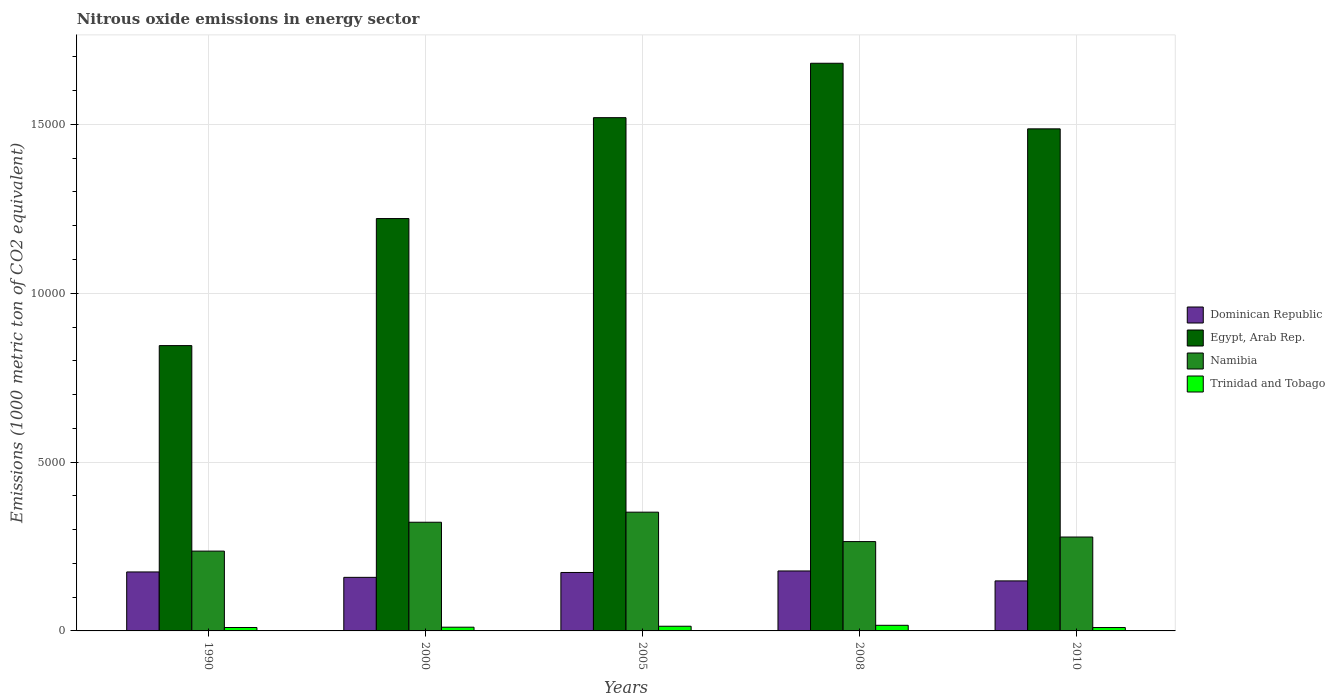How many different coloured bars are there?
Your response must be concise. 4. How many groups of bars are there?
Your answer should be very brief. 5. Are the number of bars per tick equal to the number of legend labels?
Offer a terse response. Yes. Are the number of bars on each tick of the X-axis equal?
Offer a terse response. Yes. How many bars are there on the 4th tick from the left?
Offer a terse response. 4. How many bars are there on the 1st tick from the right?
Keep it short and to the point. 4. What is the label of the 4th group of bars from the left?
Your answer should be very brief. 2008. What is the amount of nitrous oxide emitted in Namibia in 2010?
Provide a short and direct response. 2780.9. Across all years, what is the maximum amount of nitrous oxide emitted in Trinidad and Tobago?
Offer a very short reply. 166.3. Across all years, what is the minimum amount of nitrous oxide emitted in Dominican Republic?
Make the answer very short. 1481.5. In which year was the amount of nitrous oxide emitted in Egypt, Arab Rep. maximum?
Provide a succinct answer. 2008. What is the total amount of nitrous oxide emitted in Namibia in the graph?
Your answer should be very brief. 1.45e+04. What is the difference between the amount of nitrous oxide emitted in Namibia in 1990 and that in 2008?
Make the answer very short. -281.7. What is the difference between the amount of nitrous oxide emitted in Trinidad and Tobago in 2008 and the amount of nitrous oxide emitted in Egypt, Arab Rep. in 2010?
Offer a terse response. -1.47e+04. What is the average amount of nitrous oxide emitted in Namibia per year?
Give a very brief answer. 2905.14. In the year 2008, what is the difference between the amount of nitrous oxide emitted in Egypt, Arab Rep. and amount of nitrous oxide emitted in Trinidad and Tobago?
Make the answer very short. 1.66e+04. In how many years, is the amount of nitrous oxide emitted in Egypt, Arab Rep. greater than 13000 1000 metric ton?
Give a very brief answer. 3. What is the ratio of the amount of nitrous oxide emitted in Namibia in 2000 to that in 2005?
Provide a succinct answer. 0.92. Is the difference between the amount of nitrous oxide emitted in Egypt, Arab Rep. in 2000 and 2005 greater than the difference between the amount of nitrous oxide emitted in Trinidad and Tobago in 2000 and 2005?
Provide a succinct answer. No. What is the difference between the highest and the second highest amount of nitrous oxide emitted in Egypt, Arab Rep.?
Keep it short and to the point. 1611.4. What is the difference between the highest and the lowest amount of nitrous oxide emitted in Dominican Republic?
Ensure brevity in your answer.  294.2. Is the sum of the amount of nitrous oxide emitted in Trinidad and Tobago in 2000 and 2005 greater than the maximum amount of nitrous oxide emitted in Dominican Republic across all years?
Your answer should be compact. No. What does the 1st bar from the left in 2010 represents?
Offer a very short reply. Dominican Republic. What does the 4th bar from the right in 2005 represents?
Ensure brevity in your answer.  Dominican Republic. How many bars are there?
Your answer should be compact. 20. Are all the bars in the graph horizontal?
Your answer should be very brief. No. How many years are there in the graph?
Make the answer very short. 5. Does the graph contain any zero values?
Provide a short and direct response. No. Where does the legend appear in the graph?
Offer a terse response. Center right. What is the title of the graph?
Your answer should be very brief. Nitrous oxide emissions in energy sector. What is the label or title of the Y-axis?
Your response must be concise. Emissions (1000 metric ton of CO2 equivalent). What is the Emissions (1000 metric ton of CO2 equivalent) of Dominican Republic in 1990?
Offer a terse response. 1746.5. What is the Emissions (1000 metric ton of CO2 equivalent) in Egypt, Arab Rep. in 1990?
Your answer should be compact. 8449.9. What is the Emissions (1000 metric ton of CO2 equivalent) in Namibia in 1990?
Your response must be concise. 2363.8. What is the Emissions (1000 metric ton of CO2 equivalent) of Trinidad and Tobago in 1990?
Keep it short and to the point. 101.3. What is the Emissions (1000 metric ton of CO2 equivalent) of Dominican Republic in 2000?
Provide a succinct answer. 1586.4. What is the Emissions (1000 metric ton of CO2 equivalent) in Egypt, Arab Rep. in 2000?
Provide a short and direct response. 1.22e+04. What is the Emissions (1000 metric ton of CO2 equivalent) in Namibia in 2000?
Your response must be concise. 3218.7. What is the Emissions (1000 metric ton of CO2 equivalent) of Trinidad and Tobago in 2000?
Make the answer very short. 110.5. What is the Emissions (1000 metric ton of CO2 equivalent) in Dominican Republic in 2005?
Keep it short and to the point. 1731. What is the Emissions (1000 metric ton of CO2 equivalent) in Egypt, Arab Rep. in 2005?
Provide a succinct answer. 1.52e+04. What is the Emissions (1000 metric ton of CO2 equivalent) in Namibia in 2005?
Make the answer very short. 3516.8. What is the Emissions (1000 metric ton of CO2 equivalent) of Trinidad and Tobago in 2005?
Provide a short and direct response. 138.8. What is the Emissions (1000 metric ton of CO2 equivalent) in Dominican Republic in 2008?
Your answer should be compact. 1775.7. What is the Emissions (1000 metric ton of CO2 equivalent) of Egypt, Arab Rep. in 2008?
Your answer should be compact. 1.68e+04. What is the Emissions (1000 metric ton of CO2 equivalent) in Namibia in 2008?
Provide a succinct answer. 2645.5. What is the Emissions (1000 metric ton of CO2 equivalent) in Trinidad and Tobago in 2008?
Ensure brevity in your answer.  166.3. What is the Emissions (1000 metric ton of CO2 equivalent) of Dominican Republic in 2010?
Your answer should be compact. 1481.5. What is the Emissions (1000 metric ton of CO2 equivalent) of Egypt, Arab Rep. in 2010?
Your answer should be very brief. 1.49e+04. What is the Emissions (1000 metric ton of CO2 equivalent) in Namibia in 2010?
Your answer should be compact. 2780.9. What is the Emissions (1000 metric ton of CO2 equivalent) of Trinidad and Tobago in 2010?
Your answer should be very brief. 100.1. Across all years, what is the maximum Emissions (1000 metric ton of CO2 equivalent) of Dominican Republic?
Ensure brevity in your answer.  1775.7. Across all years, what is the maximum Emissions (1000 metric ton of CO2 equivalent) of Egypt, Arab Rep.?
Ensure brevity in your answer.  1.68e+04. Across all years, what is the maximum Emissions (1000 metric ton of CO2 equivalent) of Namibia?
Give a very brief answer. 3516.8. Across all years, what is the maximum Emissions (1000 metric ton of CO2 equivalent) in Trinidad and Tobago?
Provide a succinct answer. 166.3. Across all years, what is the minimum Emissions (1000 metric ton of CO2 equivalent) in Dominican Republic?
Your response must be concise. 1481.5. Across all years, what is the minimum Emissions (1000 metric ton of CO2 equivalent) of Egypt, Arab Rep.?
Keep it short and to the point. 8449.9. Across all years, what is the minimum Emissions (1000 metric ton of CO2 equivalent) in Namibia?
Offer a very short reply. 2363.8. Across all years, what is the minimum Emissions (1000 metric ton of CO2 equivalent) of Trinidad and Tobago?
Make the answer very short. 100.1. What is the total Emissions (1000 metric ton of CO2 equivalent) in Dominican Republic in the graph?
Make the answer very short. 8321.1. What is the total Emissions (1000 metric ton of CO2 equivalent) in Egypt, Arab Rep. in the graph?
Your answer should be compact. 6.75e+04. What is the total Emissions (1000 metric ton of CO2 equivalent) in Namibia in the graph?
Provide a succinct answer. 1.45e+04. What is the total Emissions (1000 metric ton of CO2 equivalent) of Trinidad and Tobago in the graph?
Keep it short and to the point. 617. What is the difference between the Emissions (1000 metric ton of CO2 equivalent) of Dominican Republic in 1990 and that in 2000?
Your answer should be very brief. 160.1. What is the difference between the Emissions (1000 metric ton of CO2 equivalent) of Egypt, Arab Rep. in 1990 and that in 2000?
Offer a terse response. -3762.5. What is the difference between the Emissions (1000 metric ton of CO2 equivalent) in Namibia in 1990 and that in 2000?
Ensure brevity in your answer.  -854.9. What is the difference between the Emissions (1000 metric ton of CO2 equivalent) of Trinidad and Tobago in 1990 and that in 2000?
Offer a very short reply. -9.2. What is the difference between the Emissions (1000 metric ton of CO2 equivalent) of Egypt, Arab Rep. in 1990 and that in 2005?
Make the answer very short. -6750.1. What is the difference between the Emissions (1000 metric ton of CO2 equivalent) in Namibia in 1990 and that in 2005?
Your answer should be very brief. -1153. What is the difference between the Emissions (1000 metric ton of CO2 equivalent) in Trinidad and Tobago in 1990 and that in 2005?
Provide a short and direct response. -37.5. What is the difference between the Emissions (1000 metric ton of CO2 equivalent) in Dominican Republic in 1990 and that in 2008?
Your answer should be very brief. -29.2. What is the difference between the Emissions (1000 metric ton of CO2 equivalent) in Egypt, Arab Rep. in 1990 and that in 2008?
Give a very brief answer. -8361.5. What is the difference between the Emissions (1000 metric ton of CO2 equivalent) of Namibia in 1990 and that in 2008?
Your answer should be very brief. -281.7. What is the difference between the Emissions (1000 metric ton of CO2 equivalent) of Trinidad and Tobago in 1990 and that in 2008?
Ensure brevity in your answer.  -65. What is the difference between the Emissions (1000 metric ton of CO2 equivalent) of Dominican Republic in 1990 and that in 2010?
Your answer should be very brief. 265. What is the difference between the Emissions (1000 metric ton of CO2 equivalent) of Egypt, Arab Rep. in 1990 and that in 2010?
Make the answer very short. -6418.9. What is the difference between the Emissions (1000 metric ton of CO2 equivalent) in Namibia in 1990 and that in 2010?
Provide a short and direct response. -417.1. What is the difference between the Emissions (1000 metric ton of CO2 equivalent) in Trinidad and Tobago in 1990 and that in 2010?
Your answer should be very brief. 1.2. What is the difference between the Emissions (1000 metric ton of CO2 equivalent) of Dominican Republic in 2000 and that in 2005?
Make the answer very short. -144.6. What is the difference between the Emissions (1000 metric ton of CO2 equivalent) in Egypt, Arab Rep. in 2000 and that in 2005?
Offer a very short reply. -2987.6. What is the difference between the Emissions (1000 metric ton of CO2 equivalent) in Namibia in 2000 and that in 2005?
Give a very brief answer. -298.1. What is the difference between the Emissions (1000 metric ton of CO2 equivalent) of Trinidad and Tobago in 2000 and that in 2005?
Your answer should be compact. -28.3. What is the difference between the Emissions (1000 metric ton of CO2 equivalent) of Dominican Republic in 2000 and that in 2008?
Your answer should be compact. -189.3. What is the difference between the Emissions (1000 metric ton of CO2 equivalent) of Egypt, Arab Rep. in 2000 and that in 2008?
Your answer should be very brief. -4599. What is the difference between the Emissions (1000 metric ton of CO2 equivalent) of Namibia in 2000 and that in 2008?
Ensure brevity in your answer.  573.2. What is the difference between the Emissions (1000 metric ton of CO2 equivalent) of Trinidad and Tobago in 2000 and that in 2008?
Provide a succinct answer. -55.8. What is the difference between the Emissions (1000 metric ton of CO2 equivalent) of Dominican Republic in 2000 and that in 2010?
Provide a short and direct response. 104.9. What is the difference between the Emissions (1000 metric ton of CO2 equivalent) in Egypt, Arab Rep. in 2000 and that in 2010?
Offer a terse response. -2656.4. What is the difference between the Emissions (1000 metric ton of CO2 equivalent) in Namibia in 2000 and that in 2010?
Give a very brief answer. 437.8. What is the difference between the Emissions (1000 metric ton of CO2 equivalent) in Trinidad and Tobago in 2000 and that in 2010?
Make the answer very short. 10.4. What is the difference between the Emissions (1000 metric ton of CO2 equivalent) in Dominican Republic in 2005 and that in 2008?
Make the answer very short. -44.7. What is the difference between the Emissions (1000 metric ton of CO2 equivalent) of Egypt, Arab Rep. in 2005 and that in 2008?
Your answer should be very brief. -1611.4. What is the difference between the Emissions (1000 metric ton of CO2 equivalent) of Namibia in 2005 and that in 2008?
Provide a succinct answer. 871.3. What is the difference between the Emissions (1000 metric ton of CO2 equivalent) in Trinidad and Tobago in 2005 and that in 2008?
Your response must be concise. -27.5. What is the difference between the Emissions (1000 metric ton of CO2 equivalent) in Dominican Republic in 2005 and that in 2010?
Your response must be concise. 249.5. What is the difference between the Emissions (1000 metric ton of CO2 equivalent) of Egypt, Arab Rep. in 2005 and that in 2010?
Your answer should be very brief. 331.2. What is the difference between the Emissions (1000 metric ton of CO2 equivalent) of Namibia in 2005 and that in 2010?
Your answer should be compact. 735.9. What is the difference between the Emissions (1000 metric ton of CO2 equivalent) of Trinidad and Tobago in 2005 and that in 2010?
Give a very brief answer. 38.7. What is the difference between the Emissions (1000 metric ton of CO2 equivalent) of Dominican Republic in 2008 and that in 2010?
Your answer should be compact. 294.2. What is the difference between the Emissions (1000 metric ton of CO2 equivalent) in Egypt, Arab Rep. in 2008 and that in 2010?
Your response must be concise. 1942.6. What is the difference between the Emissions (1000 metric ton of CO2 equivalent) in Namibia in 2008 and that in 2010?
Give a very brief answer. -135.4. What is the difference between the Emissions (1000 metric ton of CO2 equivalent) in Trinidad and Tobago in 2008 and that in 2010?
Your answer should be very brief. 66.2. What is the difference between the Emissions (1000 metric ton of CO2 equivalent) in Dominican Republic in 1990 and the Emissions (1000 metric ton of CO2 equivalent) in Egypt, Arab Rep. in 2000?
Ensure brevity in your answer.  -1.05e+04. What is the difference between the Emissions (1000 metric ton of CO2 equivalent) of Dominican Republic in 1990 and the Emissions (1000 metric ton of CO2 equivalent) of Namibia in 2000?
Provide a short and direct response. -1472.2. What is the difference between the Emissions (1000 metric ton of CO2 equivalent) in Dominican Republic in 1990 and the Emissions (1000 metric ton of CO2 equivalent) in Trinidad and Tobago in 2000?
Make the answer very short. 1636. What is the difference between the Emissions (1000 metric ton of CO2 equivalent) in Egypt, Arab Rep. in 1990 and the Emissions (1000 metric ton of CO2 equivalent) in Namibia in 2000?
Offer a very short reply. 5231.2. What is the difference between the Emissions (1000 metric ton of CO2 equivalent) in Egypt, Arab Rep. in 1990 and the Emissions (1000 metric ton of CO2 equivalent) in Trinidad and Tobago in 2000?
Provide a succinct answer. 8339.4. What is the difference between the Emissions (1000 metric ton of CO2 equivalent) of Namibia in 1990 and the Emissions (1000 metric ton of CO2 equivalent) of Trinidad and Tobago in 2000?
Make the answer very short. 2253.3. What is the difference between the Emissions (1000 metric ton of CO2 equivalent) of Dominican Republic in 1990 and the Emissions (1000 metric ton of CO2 equivalent) of Egypt, Arab Rep. in 2005?
Offer a terse response. -1.35e+04. What is the difference between the Emissions (1000 metric ton of CO2 equivalent) in Dominican Republic in 1990 and the Emissions (1000 metric ton of CO2 equivalent) in Namibia in 2005?
Give a very brief answer. -1770.3. What is the difference between the Emissions (1000 metric ton of CO2 equivalent) of Dominican Republic in 1990 and the Emissions (1000 metric ton of CO2 equivalent) of Trinidad and Tobago in 2005?
Your answer should be compact. 1607.7. What is the difference between the Emissions (1000 metric ton of CO2 equivalent) of Egypt, Arab Rep. in 1990 and the Emissions (1000 metric ton of CO2 equivalent) of Namibia in 2005?
Your answer should be very brief. 4933.1. What is the difference between the Emissions (1000 metric ton of CO2 equivalent) in Egypt, Arab Rep. in 1990 and the Emissions (1000 metric ton of CO2 equivalent) in Trinidad and Tobago in 2005?
Provide a short and direct response. 8311.1. What is the difference between the Emissions (1000 metric ton of CO2 equivalent) of Namibia in 1990 and the Emissions (1000 metric ton of CO2 equivalent) of Trinidad and Tobago in 2005?
Keep it short and to the point. 2225. What is the difference between the Emissions (1000 metric ton of CO2 equivalent) of Dominican Republic in 1990 and the Emissions (1000 metric ton of CO2 equivalent) of Egypt, Arab Rep. in 2008?
Your response must be concise. -1.51e+04. What is the difference between the Emissions (1000 metric ton of CO2 equivalent) in Dominican Republic in 1990 and the Emissions (1000 metric ton of CO2 equivalent) in Namibia in 2008?
Ensure brevity in your answer.  -899. What is the difference between the Emissions (1000 metric ton of CO2 equivalent) in Dominican Republic in 1990 and the Emissions (1000 metric ton of CO2 equivalent) in Trinidad and Tobago in 2008?
Give a very brief answer. 1580.2. What is the difference between the Emissions (1000 metric ton of CO2 equivalent) of Egypt, Arab Rep. in 1990 and the Emissions (1000 metric ton of CO2 equivalent) of Namibia in 2008?
Your answer should be very brief. 5804.4. What is the difference between the Emissions (1000 metric ton of CO2 equivalent) of Egypt, Arab Rep. in 1990 and the Emissions (1000 metric ton of CO2 equivalent) of Trinidad and Tobago in 2008?
Your response must be concise. 8283.6. What is the difference between the Emissions (1000 metric ton of CO2 equivalent) of Namibia in 1990 and the Emissions (1000 metric ton of CO2 equivalent) of Trinidad and Tobago in 2008?
Give a very brief answer. 2197.5. What is the difference between the Emissions (1000 metric ton of CO2 equivalent) in Dominican Republic in 1990 and the Emissions (1000 metric ton of CO2 equivalent) in Egypt, Arab Rep. in 2010?
Offer a very short reply. -1.31e+04. What is the difference between the Emissions (1000 metric ton of CO2 equivalent) in Dominican Republic in 1990 and the Emissions (1000 metric ton of CO2 equivalent) in Namibia in 2010?
Keep it short and to the point. -1034.4. What is the difference between the Emissions (1000 metric ton of CO2 equivalent) of Dominican Republic in 1990 and the Emissions (1000 metric ton of CO2 equivalent) of Trinidad and Tobago in 2010?
Your response must be concise. 1646.4. What is the difference between the Emissions (1000 metric ton of CO2 equivalent) in Egypt, Arab Rep. in 1990 and the Emissions (1000 metric ton of CO2 equivalent) in Namibia in 2010?
Keep it short and to the point. 5669. What is the difference between the Emissions (1000 metric ton of CO2 equivalent) in Egypt, Arab Rep. in 1990 and the Emissions (1000 metric ton of CO2 equivalent) in Trinidad and Tobago in 2010?
Your answer should be very brief. 8349.8. What is the difference between the Emissions (1000 metric ton of CO2 equivalent) in Namibia in 1990 and the Emissions (1000 metric ton of CO2 equivalent) in Trinidad and Tobago in 2010?
Ensure brevity in your answer.  2263.7. What is the difference between the Emissions (1000 metric ton of CO2 equivalent) of Dominican Republic in 2000 and the Emissions (1000 metric ton of CO2 equivalent) of Egypt, Arab Rep. in 2005?
Offer a very short reply. -1.36e+04. What is the difference between the Emissions (1000 metric ton of CO2 equivalent) of Dominican Republic in 2000 and the Emissions (1000 metric ton of CO2 equivalent) of Namibia in 2005?
Offer a terse response. -1930.4. What is the difference between the Emissions (1000 metric ton of CO2 equivalent) of Dominican Republic in 2000 and the Emissions (1000 metric ton of CO2 equivalent) of Trinidad and Tobago in 2005?
Make the answer very short. 1447.6. What is the difference between the Emissions (1000 metric ton of CO2 equivalent) in Egypt, Arab Rep. in 2000 and the Emissions (1000 metric ton of CO2 equivalent) in Namibia in 2005?
Keep it short and to the point. 8695.6. What is the difference between the Emissions (1000 metric ton of CO2 equivalent) of Egypt, Arab Rep. in 2000 and the Emissions (1000 metric ton of CO2 equivalent) of Trinidad and Tobago in 2005?
Offer a terse response. 1.21e+04. What is the difference between the Emissions (1000 metric ton of CO2 equivalent) of Namibia in 2000 and the Emissions (1000 metric ton of CO2 equivalent) of Trinidad and Tobago in 2005?
Ensure brevity in your answer.  3079.9. What is the difference between the Emissions (1000 metric ton of CO2 equivalent) of Dominican Republic in 2000 and the Emissions (1000 metric ton of CO2 equivalent) of Egypt, Arab Rep. in 2008?
Provide a succinct answer. -1.52e+04. What is the difference between the Emissions (1000 metric ton of CO2 equivalent) of Dominican Republic in 2000 and the Emissions (1000 metric ton of CO2 equivalent) of Namibia in 2008?
Offer a very short reply. -1059.1. What is the difference between the Emissions (1000 metric ton of CO2 equivalent) of Dominican Republic in 2000 and the Emissions (1000 metric ton of CO2 equivalent) of Trinidad and Tobago in 2008?
Your answer should be very brief. 1420.1. What is the difference between the Emissions (1000 metric ton of CO2 equivalent) in Egypt, Arab Rep. in 2000 and the Emissions (1000 metric ton of CO2 equivalent) in Namibia in 2008?
Keep it short and to the point. 9566.9. What is the difference between the Emissions (1000 metric ton of CO2 equivalent) in Egypt, Arab Rep. in 2000 and the Emissions (1000 metric ton of CO2 equivalent) in Trinidad and Tobago in 2008?
Give a very brief answer. 1.20e+04. What is the difference between the Emissions (1000 metric ton of CO2 equivalent) in Namibia in 2000 and the Emissions (1000 metric ton of CO2 equivalent) in Trinidad and Tobago in 2008?
Your answer should be very brief. 3052.4. What is the difference between the Emissions (1000 metric ton of CO2 equivalent) of Dominican Republic in 2000 and the Emissions (1000 metric ton of CO2 equivalent) of Egypt, Arab Rep. in 2010?
Ensure brevity in your answer.  -1.33e+04. What is the difference between the Emissions (1000 metric ton of CO2 equivalent) of Dominican Republic in 2000 and the Emissions (1000 metric ton of CO2 equivalent) of Namibia in 2010?
Provide a short and direct response. -1194.5. What is the difference between the Emissions (1000 metric ton of CO2 equivalent) of Dominican Republic in 2000 and the Emissions (1000 metric ton of CO2 equivalent) of Trinidad and Tobago in 2010?
Offer a very short reply. 1486.3. What is the difference between the Emissions (1000 metric ton of CO2 equivalent) of Egypt, Arab Rep. in 2000 and the Emissions (1000 metric ton of CO2 equivalent) of Namibia in 2010?
Give a very brief answer. 9431.5. What is the difference between the Emissions (1000 metric ton of CO2 equivalent) of Egypt, Arab Rep. in 2000 and the Emissions (1000 metric ton of CO2 equivalent) of Trinidad and Tobago in 2010?
Your answer should be very brief. 1.21e+04. What is the difference between the Emissions (1000 metric ton of CO2 equivalent) of Namibia in 2000 and the Emissions (1000 metric ton of CO2 equivalent) of Trinidad and Tobago in 2010?
Your answer should be very brief. 3118.6. What is the difference between the Emissions (1000 metric ton of CO2 equivalent) of Dominican Republic in 2005 and the Emissions (1000 metric ton of CO2 equivalent) of Egypt, Arab Rep. in 2008?
Provide a short and direct response. -1.51e+04. What is the difference between the Emissions (1000 metric ton of CO2 equivalent) in Dominican Republic in 2005 and the Emissions (1000 metric ton of CO2 equivalent) in Namibia in 2008?
Your response must be concise. -914.5. What is the difference between the Emissions (1000 metric ton of CO2 equivalent) of Dominican Republic in 2005 and the Emissions (1000 metric ton of CO2 equivalent) of Trinidad and Tobago in 2008?
Ensure brevity in your answer.  1564.7. What is the difference between the Emissions (1000 metric ton of CO2 equivalent) in Egypt, Arab Rep. in 2005 and the Emissions (1000 metric ton of CO2 equivalent) in Namibia in 2008?
Offer a very short reply. 1.26e+04. What is the difference between the Emissions (1000 metric ton of CO2 equivalent) of Egypt, Arab Rep. in 2005 and the Emissions (1000 metric ton of CO2 equivalent) of Trinidad and Tobago in 2008?
Offer a very short reply. 1.50e+04. What is the difference between the Emissions (1000 metric ton of CO2 equivalent) in Namibia in 2005 and the Emissions (1000 metric ton of CO2 equivalent) in Trinidad and Tobago in 2008?
Your answer should be compact. 3350.5. What is the difference between the Emissions (1000 metric ton of CO2 equivalent) of Dominican Republic in 2005 and the Emissions (1000 metric ton of CO2 equivalent) of Egypt, Arab Rep. in 2010?
Your response must be concise. -1.31e+04. What is the difference between the Emissions (1000 metric ton of CO2 equivalent) in Dominican Republic in 2005 and the Emissions (1000 metric ton of CO2 equivalent) in Namibia in 2010?
Offer a terse response. -1049.9. What is the difference between the Emissions (1000 metric ton of CO2 equivalent) in Dominican Republic in 2005 and the Emissions (1000 metric ton of CO2 equivalent) in Trinidad and Tobago in 2010?
Provide a short and direct response. 1630.9. What is the difference between the Emissions (1000 metric ton of CO2 equivalent) of Egypt, Arab Rep. in 2005 and the Emissions (1000 metric ton of CO2 equivalent) of Namibia in 2010?
Give a very brief answer. 1.24e+04. What is the difference between the Emissions (1000 metric ton of CO2 equivalent) of Egypt, Arab Rep. in 2005 and the Emissions (1000 metric ton of CO2 equivalent) of Trinidad and Tobago in 2010?
Keep it short and to the point. 1.51e+04. What is the difference between the Emissions (1000 metric ton of CO2 equivalent) of Namibia in 2005 and the Emissions (1000 metric ton of CO2 equivalent) of Trinidad and Tobago in 2010?
Keep it short and to the point. 3416.7. What is the difference between the Emissions (1000 metric ton of CO2 equivalent) in Dominican Republic in 2008 and the Emissions (1000 metric ton of CO2 equivalent) in Egypt, Arab Rep. in 2010?
Make the answer very short. -1.31e+04. What is the difference between the Emissions (1000 metric ton of CO2 equivalent) in Dominican Republic in 2008 and the Emissions (1000 metric ton of CO2 equivalent) in Namibia in 2010?
Keep it short and to the point. -1005.2. What is the difference between the Emissions (1000 metric ton of CO2 equivalent) of Dominican Republic in 2008 and the Emissions (1000 metric ton of CO2 equivalent) of Trinidad and Tobago in 2010?
Your answer should be very brief. 1675.6. What is the difference between the Emissions (1000 metric ton of CO2 equivalent) in Egypt, Arab Rep. in 2008 and the Emissions (1000 metric ton of CO2 equivalent) in Namibia in 2010?
Provide a short and direct response. 1.40e+04. What is the difference between the Emissions (1000 metric ton of CO2 equivalent) of Egypt, Arab Rep. in 2008 and the Emissions (1000 metric ton of CO2 equivalent) of Trinidad and Tobago in 2010?
Provide a short and direct response. 1.67e+04. What is the difference between the Emissions (1000 metric ton of CO2 equivalent) of Namibia in 2008 and the Emissions (1000 metric ton of CO2 equivalent) of Trinidad and Tobago in 2010?
Offer a terse response. 2545.4. What is the average Emissions (1000 metric ton of CO2 equivalent) of Dominican Republic per year?
Keep it short and to the point. 1664.22. What is the average Emissions (1000 metric ton of CO2 equivalent) in Egypt, Arab Rep. per year?
Provide a short and direct response. 1.35e+04. What is the average Emissions (1000 metric ton of CO2 equivalent) in Namibia per year?
Your answer should be compact. 2905.14. What is the average Emissions (1000 metric ton of CO2 equivalent) of Trinidad and Tobago per year?
Give a very brief answer. 123.4. In the year 1990, what is the difference between the Emissions (1000 metric ton of CO2 equivalent) in Dominican Republic and Emissions (1000 metric ton of CO2 equivalent) in Egypt, Arab Rep.?
Offer a terse response. -6703.4. In the year 1990, what is the difference between the Emissions (1000 metric ton of CO2 equivalent) of Dominican Republic and Emissions (1000 metric ton of CO2 equivalent) of Namibia?
Keep it short and to the point. -617.3. In the year 1990, what is the difference between the Emissions (1000 metric ton of CO2 equivalent) of Dominican Republic and Emissions (1000 metric ton of CO2 equivalent) of Trinidad and Tobago?
Give a very brief answer. 1645.2. In the year 1990, what is the difference between the Emissions (1000 metric ton of CO2 equivalent) in Egypt, Arab Rep. and Emissions (1000 metric ton of CO2 equivalent) in Namibia?
Make the answer very short. 6086.1. In the year 1990, what is the difference between the Emissions (1000 metric ton of CO2 equivalent) of Egypt, Arab Rep. and Emissions (1000 metric ton of CO2 equivalent) of Trinidad and Tobago?
Your response must be concise. 8348.6. In the year 1990, what is the difference between the Emissions (1000 metric ton of CO2 equivalent) in Namibia and Emissions (1000 metric ton of CO2 equivalent) in Trinidad and Tobago?
Your answer should be very brief. 2262.5. In the year 2000, what is the difference between the Emissions (1000 metric ton of CO2 equivalent) of Dominican Republic and Emissions (1000 metric ton of CO2 equivalent) of Egypt, Arab Rep.?
Provide a succinct answer. -1.06e+04. In the year 2000, what is the difference between the Emissions (1000 metric ton of CO2 equivalent) in Dominican Republic and Emissions (1000 metric ton of CO2 equivalent) in Namibia?
Give a very brief answer. -1632.3. In the year 2000, what is the difference between the Emissions (1000 metric ton of CO2 equivalent) of Dominican Republic and Emissions (1000 metric ton of CO2 equivalent) of Trinidad and Tobago?
Provide a short and direct response. 1475.9. In the year 2000, what is the difference between the Emissions (1000 metric ton of CO2 equivalent) of Egypt, Arab Rep. and Emissions (1000 metric ton of CO2 equivalent) of Namibia?
Give a very brief answer. 8993.7. In the year 2000, what is the difference between the Emissions (1000 metric ton of CO2 equivalent) in Egypt, Arab Rep. and Emissions (1000 metric ton of CO2 equivalent) in Trinidad and Tobago?
Offer a terse response. 1.21e+04. In the year 2000, what is the difference between the Emissions (1000 metric ton of CO2 equivalent) of Namibia and Emissions (1000 metric ton of CO2 equivalent) of Trinidad and Tobago?
Your response must be concise. 3108.2. In the year 2005, what is the difference between the Emissions (1000 metric ton of CO2 equivalent) in Dominican Republic and Emissions (1000 metric ton of CO2 equivalent) in Egypt, Arab Rep.?
Offer a very short reply. -1.35e+04. In the year 2005, what is the difference between the Emissions (1000 metric ton of CO2 equivalent) of Dominican Republic and Emissions (1000 metric ton of CO2 equivalent) of Namibia?
Ensure brevity in your answer.  -1785.8. In the year 2005, what is the difference between the Emissions (1000 metric ton of CO2 equivalent) of Dominican Republic and Emissions (1000 metric ton of CO2 equivalent) of Trinidad and Tobago?
Provide a short and direct response. 1592.2. In the year 2005, what is the difference between the Emissions (1000 metric ton of CO2 equivalent) in Egypt, Arab Rep. and Emissions (1000 metric ton of CO2 equivalent) in Namibia?
Your answer should be compact. 1.17e+04. In the year 2005, what is the difference between the Emissions (1000 metric ton of CO2 equivalent) in Egypt, Arab Rep. and Emissions (1000 metric ton of CO2 equivalent) in Trinidad and Tobago?
Give a very brief answer. 1.51e+04. In the year 2005, what is the difference between the Emissions (1000 metric ton of CO2 equivalent) in Namibia and Emissions (1000 metric ton of CO2 equivalent) in Trinidad and Tobago?
Make the answer very short. 3378. In the year 2008, what is the difference between the Emissions (1000 metric ton of CO2 equivalent) in Dominican Republic and Emissions (1000 metric ton of CO2 equivalent) in Egypt, Arab Rep.?
Make the answer very short. -1.50e+04. In the year 2008, what is the difference between the Emissions (1000 metric ton of CO2 equivalent) of Dominican Republic and Emissions (1000 metric ton of CO2 equivalent) of Namibia?
Provide a short and direct response. -869.8. In the year 2008, what is the difference between the Emissions (1000 metric ton of CO2 equivalent) in Dominican Republic and Emissions (1000 metric ton of CO2 equivalent) in Trinidad and Tobago?
Make the answer very short. 1609.4. In the year 2008, what is the difference between the Emissions (1000 metric ton of CO2 equivalent) in Egypt, Arab Rep. and Emissions (1000 metric ton of CO2 equivalent) in Namibia?
Ensure brevity in your answer.  1.42e+04. In the year 2008, what is the difference between the Emissions (1000 metric ton of CO2 equivalent) of Egypt, Arab Rep. and Emissions (1000 metric ton of CO2 equivalent) of Trinidad and Tobago?
Provide a short and direct response. 1.66e+04. In the year 2008, what is the difference between the Emissions (1000 metric ton of CO2 equivalent) of Namibia and Emissions (1000 metric ton of CO2 equivalent) of Trinidad and Tobago?
Provide a succinct answer. 2479.2. In the year 2010, what is the difference between the Emissions (1000 metric ton of CO2 equivalent) of Dominican Republic and Emissions (1000 metric ton of CO2 equivalent) of Egypt, Arab Rep.?
Your response must be concise. -1.34e+04. In the year 2010, what is the difference between the Emissions (1000 metric ton of CO2 equivalent) of Dominican Republic and Emissions (1000 metric ton of CO2 equivalent) of Namibia?
Your answer should be compact. -1299.4. In the year 2010, what is the difference between the Emissions (1000 metric ton of CO2 equivalent) of Dominican Republic and Emissions (1000 metric ton of CO2 equivalent) of Trinidad and Tobago?
Your response must be concise. 1381.4. In the year 2010, what is the difference between the Emissions (1000 metric ton of CO2 equivalent) of Egypt, Arab Rep. and Emissions (1000 metric ton of CO2 equivalent) of Namibia?
Your response must be concise. 1.21e+04. In the year 2010, what is the difference between the Emissions (1000 metric ton of CO2 equivalent) in Egypt, Arab Rep. and Emissions (1000 metric ton of CO2 equivalent) in Trinidad and Tobago?
Ensure brevity in your answer.  1.48e+04. In the year 2010, what is the difference between the Emissions (1000 metric ton of CO2 equivalent) of Namibia and Emissions (1000 metric ton of CO2 equivalent) of Trinidad and Tobago?
Make the answer very short. 2680.8. What is the ratio of the Emissions (1000 metric ton of CO2 equivalent) of Dominican Republic in 1990 to that in 2000?
Keep it short and to the point. 1.1. What is the ratio of the Emissions (1000 metric ton of CO2 equivalent) in Egypt, Arab Rep. in 1990 to that in 2000?
Your response must be concise. 0.69. What is the ratio of the Emissions (1000 metric ton of CO2 equivalent) in Namibia in 1990 to that in 2000?
Keep it short and to the point. 0.73. What is the ratio of the Emissions (1000 metric ton of CO2 equivalent) of Egypt, Arab Rep. in 1990 to that in 2005?
Your response must be concise. 0.56. What is the ratio of the Emissions (1000 metric ton of CO2 equivalent) of Namibia in 1990 to that in 2005?
Keep it short and to the point. 0.67. What is the ratio of the Emissions (1000 metric ton of CO2 equivalent) in Trinidad and Tobago in 1990 to that in 2005?
Offer a very short reply. 0.73. What is the ratio of the Emissions (1000 metric ton of CO2 equivalent) in Dominican Republic in 1990 to that in 2008?
Your answer should be very brief. 0.98. What is the ratio of the Emissions (1000 metric ton of CO2 equivalent) of Egypt, Arab Rep. in 1990 to that in 2008?
Provide a succinct answer. 0.5. What is the ratio of the Emissions (1000 metric ton of CO2 equivalent) of Namibia in 1990 to that in 2008?
Give a very brief answer. 0.89. What is the ratio of the Emissions (1000 metric ton of CO2 equivalent) of Trinidad and Tobago in 1990 to that in 2008?
Make the answer very short. 0.61. What is the ratio of the Emissions (1000 metric ton of CO2 equivalent) of Dominican Republic in 1990 to that in 2010?
Your answer should be compact. 1.18. What is the ratio of the Emissions (1000 metric ton of CO2 equivalent) in Egypt, Arab Rep. in 1990 to that in 2010?
Your response must be concise. 0.57. What is the ratio of the Emissions (1000 metric ton of CO2 equivalent) of Namibia in 1990 to that in 2010?
Keep it short and to the point. 0.85. What is the ratio of the Emissions (1000 metric ton of CO2 equivalent) in Dominican Republic in 2000 to that in 2005?
Give a very brief answer. 0.92. What is the ratio of the Emissions (1000 metric ton of CO2 equivalent) in Egypt, Arab Rep. in 2000 to that in 2005?
Your answer should be very brief. 0.8. What is the ratio of the Emissions (1000 metric ton of CO2 equivalent) in Namibia in 2000 to that in 2005?
Offer a very short reply. 0.92. What is the ratio of the Emissions (1000 metric ton of CO2 equivalent) in Trinidad and Tobago in 2000 to that in 2005?
Keep it short and to the point. 0.8. What is the ratio of the Emissions (1000 metric ton of CO2 equivalent) of Dominican Republic in 2000 to that in 2008?
Make the answer very short. 0.89. What is the ratio of the Emissions (1000 metric ton of CO2 equivalent) of Egypt, Arab Rep. in 2000 to that in 2008?
Offer a very short reply. 0.73. What is the ratio of the Emissions (1000 metric ton of CO2 equivalent) in Namibia in 2000 to that in 2008?
Your answer should be compact. 1.22. What is the ratio of the Emissions (1000 metric ton of CO2 equivalent) of Trinidad and Tobago in 2000 to that in 2008?
Ensure brevity in your answer.  0.66. What is the ratio of the Emissions (1000 metric ton of CO2 equivalent) in Dominican Republic in 2000 to that in 2010?
Keep it short and to the point. 1.07. What is the ratio of the Emissions (1000 metric ton of CO2 equivalent) in Egypt, Arab Rep. in 2000 to that in 2010?
Provide a short and direct response. 0.82. What is the ratio of the Emissions (1000 metric ton of CO2 equivalent) in Namibia in 2000 to that in 2010?
Provide a short and direct response. 1.16. What is the ratio of the Emissions (1000 metric ton of CO2 equivalent) of Trinidad and Tobago in 2000 to that in 2010?
Keep it short and to the point. 1.1. What is the ratio of the Emissions (1000 metric ton of CO2 equivalent) of Dominican Republic in 2005 to that in 2008?
Provide a short and direct response. 0.97. What is the ratio of the Emissions (1000 metric ton of CO2 equivalent) of Egypt, Arab Rep. in 2005 to that in 2008?
Your answer should be very brief. 0.9. What is the ratio of the Emissions (1000 metric ton of CO2 equivalent) in Namibia in 2005 to that in 2008?
Offer a very short reply. 1.33. What is the ratio of the Emissions (1000 metric ton of CO2 equivalent) in Trinidad and Tobago in 2005 to that in 2008?
Your answer should be compact. 0.83. What is the ratio of the Emissions (1000 metric ton of CO2 equivalent) of Dominican Republic in 2005 to that in 2010?
Provide a succinct answer. 1.17. What is the ratio of the Emissions (1000 metric ton of CO2 equivalent) of Egypt, Arab Rep. in 2005 to that in 2010?
Offer a terse response. 1.02. What is the ratio of the Emissions (1000 metric ton of CO2 equivalent) in Namibia in 2005 to that in 2010?
Keep it short and to the point. 1.26. What is the ratio of the Emissions (1000 metric ton of CO2 equivalent) in Trinidad and Tobago in 2005 to that in 2010?
Give a very brief answer. 1.39. What is the ratio of the Emissions (1000 metric ton of CO2 equivalent) of Dominican Republic in 2008 to that in 2010?
Your answer should be very brief. 1.2. What is the ratio of the Emissions (1000 metric ton of CO2 equivalent) of Egypt, Arab Rep. in 2008 to that in 2010?
Give a very brief answer. 1.13. What is the ratio of the Emissions (1000 metric ton of CO2 equivalent) in Namibia in 2008 to that in 2010?
Give a very brief answer. 0.95. What is the ratio of the Emissions (1000 metric ton of CO2 equivalent) of Trinidad and Tobago in 2008 to that in 2010?
Give a very brief answer. 1.66. What is the difference between the highest and the second highest Emissions (1000 metric ton of CO2 equivalent) of Dominican Republic?
Ensure brevity in your answer.  29.2. What is the difference between the highest and the second highest Emissions (1000 metric ton of CO2 equivalent) of Egypt, Arab Rep.?
Provide a succinct answer. 1611.4. What is the difference between the highest and the second highest Emissions (1000 metric ton of CO2 equivalent) in Namibia?
Offer a terse response. 298.1. What is the difference between the highest and the lowest Emissions (1000 metric ton of CO2 equivalent) in Dominican Republic?
Provide a succinct answer. 294.2. What is the difference between the highest and the lowest Emissions (1000 metric ton of CO2 equivalent) of Egypt, Arab Rep.?
Keep it short and to the point. 8361.5. What is the difference between the highest and the lowest Emissions (1000 metric ton of CO2 equivalent) of Namibia?
Ensure brevity in your answer.  1153. What is the difference between the highest and the lowest Emissions (1000 metric ton of CO2 equivalent) in Trinidad and Tobago?
Offer a terse response. 66.2. 